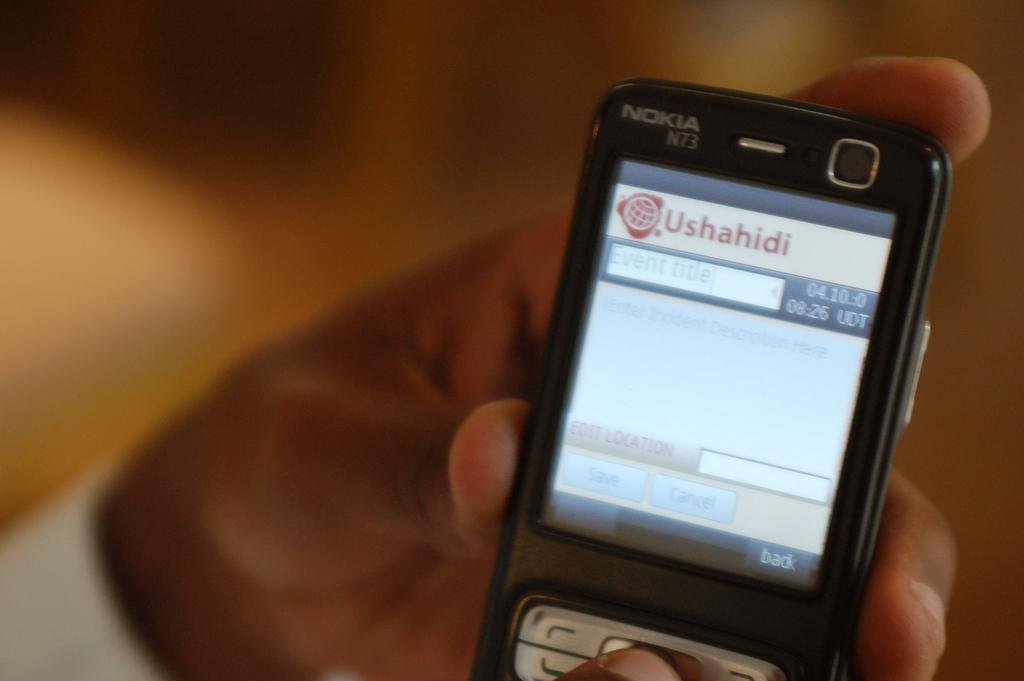What object is being held in the foreground area of the image? There is a phone in the hand in the foreground area of the image. Can you describe the background of the image? The background of the image is blurry. What type of art is being created in the image? There is no indication of any art being created in the image. What month is it in the image? There is no information about the month in the image. 